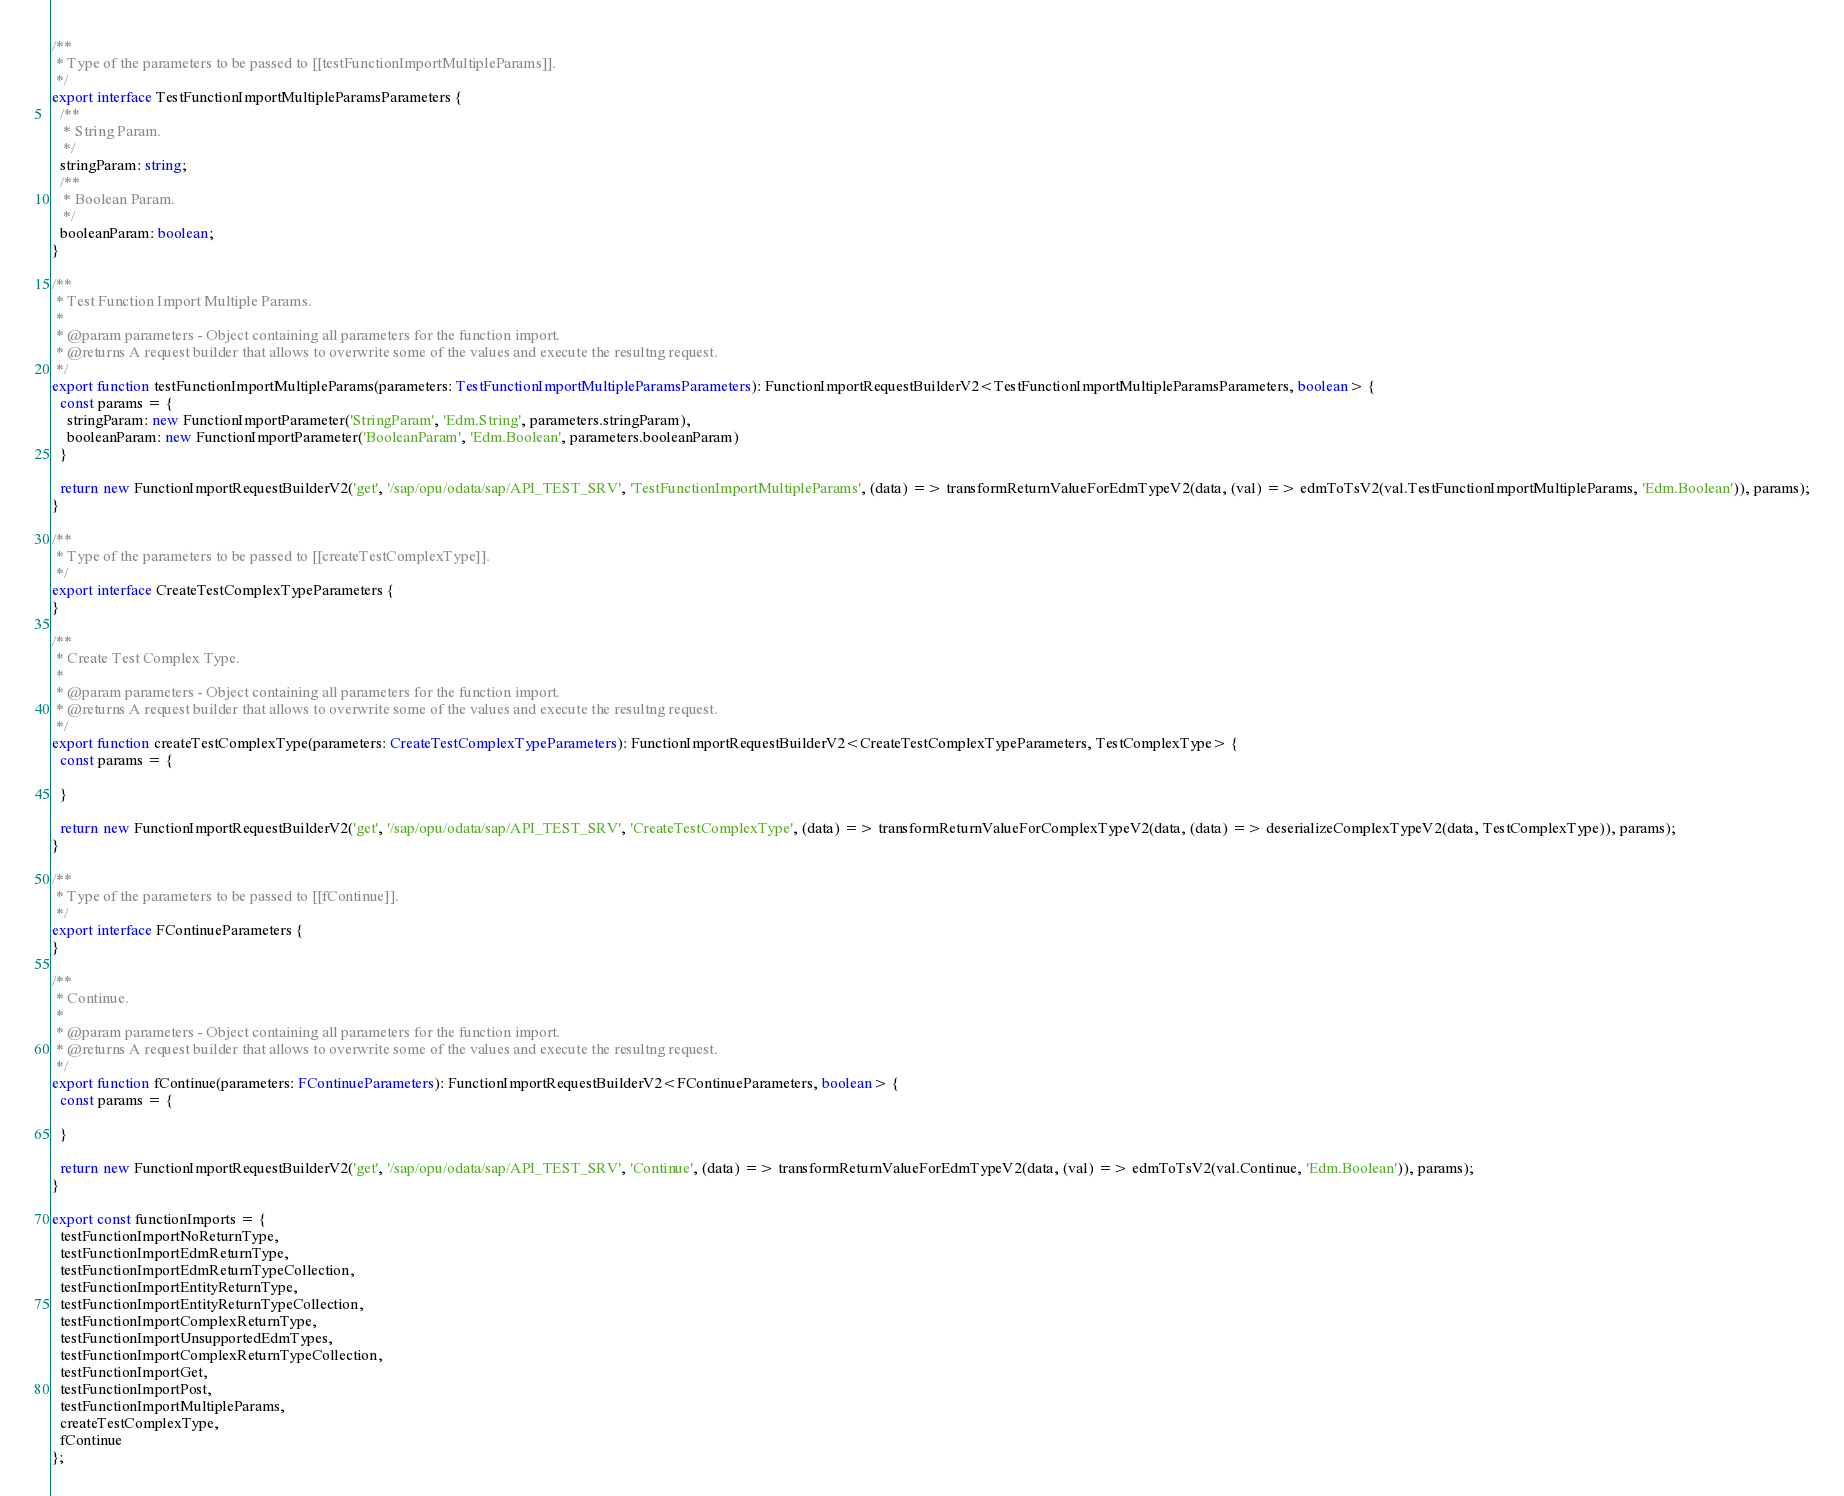<code> <loc_0><loc_0><loc_500><loc_500><_TypeScript_>
/**
 * Type of the parameters to be passed to [[testFunctionImportMultipleParams]].
 */
export interface TestFunctionImportMultipleParamsParameters {
  /**
   * String Param.
   */
  stringParam: string;
  /**
   * Boolean Param.
   */
  booleanParam: boolean;
}

/**
 * Test Function Import Multiple Params.
 *
 * @param parameters - Object containing all parameters for the function import.
 * @returns A request builder that allows to overwrite some of the values and execute the resultng request.
 */
export function testFunctionImportMultipleParams(parameters: TestFunctionImportMultipleParamsParameters): FunctionImportRequestBuilderV2<TestFunctionImportMultipleParamsParameters, boolean> {
  const params = {
    stringParam: new FunctionImportParameter('StringParam', 'Edm.String', parameters.stringParam),
    booleanParam: new FunctionImportParameter('BooleanParam', 'Edm.Boolean', parameters.booleanParam)
  }

  return new FunctionImportRequestBuilderV2('get', '/sap/opu/odata/sap/API_TEST_SRV', 'TestFunctionImportMultipleParams', (data) => transformReturnValueForEdmTypeV2(data, (val) => edmToTsV2(val.TestFunctionImportMultipleParams, 'Edm.Boolean')), params);
}

/**
 * Type of the parameters to be passed to [[createTestComplexType]].
 */
export interface CreateTestComplexTypeParameters {
}

/**
 * Create Test Complex Type.
 *
 * @param parameters - Object containing all parameters for the function import.
 * @returns A request builder that allows to overwrite some of the values and execute the resultng request.
 */
export function createTestComplexType(parameters: CreateTestComplexTypeParameters): FunctionImportRequestBuilderV2<CreateTestComplexTypeParameters, TestComplexType> {
  const params = {

  }

  return new FunctionImportRequestBuilderV2('get', '/sap/opu/odata/sap/API_TEST_SRV', 'CreateTestComplexType', (data) => transformReturnValueForComplexTypeV2(data, (data) => deserializeComplexTypeV2(data, TestComplexType)), params);
}

/**
 * Type of the parameters to be passed to [[fContinue]].
 */
export interface FContinueParameters {
}

/**
 * Continue.
 *
 * @param parameters - Object containing all parameters for the function import.
 * @returns A request builder that allows to overwrite some of the values and execute the resultng request.
 */
export function fContinue(parameters: FContinueParameters): FunctionImportRequestBuilderV2<FContinueParameters, boolean> {
  const params = {

  }

  return new FunctionImportRequestBuilderV2('get', '/sap/opu/odata/sap/API_TEST_SRV', 'Continue', (data) => transformReturnValueForEdmTypeV2(data, (val) => edmToTsV2(val.Continue, 'Edm.Boolean')), params);
}

export const functionImports = {
  testFunctionImportNoReturnType,
  testFunctionImportEdmReturnType,
  testFunctionImportEdmReturnTypeCollection,
  testFunctionImportEntityReturnType,
  testFunctionImportEntityReturnTypeCollection,
  testFunctionImportComplexReturnType,
  testFunctionImportUnsupportedEdmTypes,
  testFunctionImportComplexReturnTypeCollection,
  testFunctionImportGet,
  testFunctionImportPost,
  testFunctionImportMultipleParams,
  createTestComplexType,
  fContinue
};
</code> 